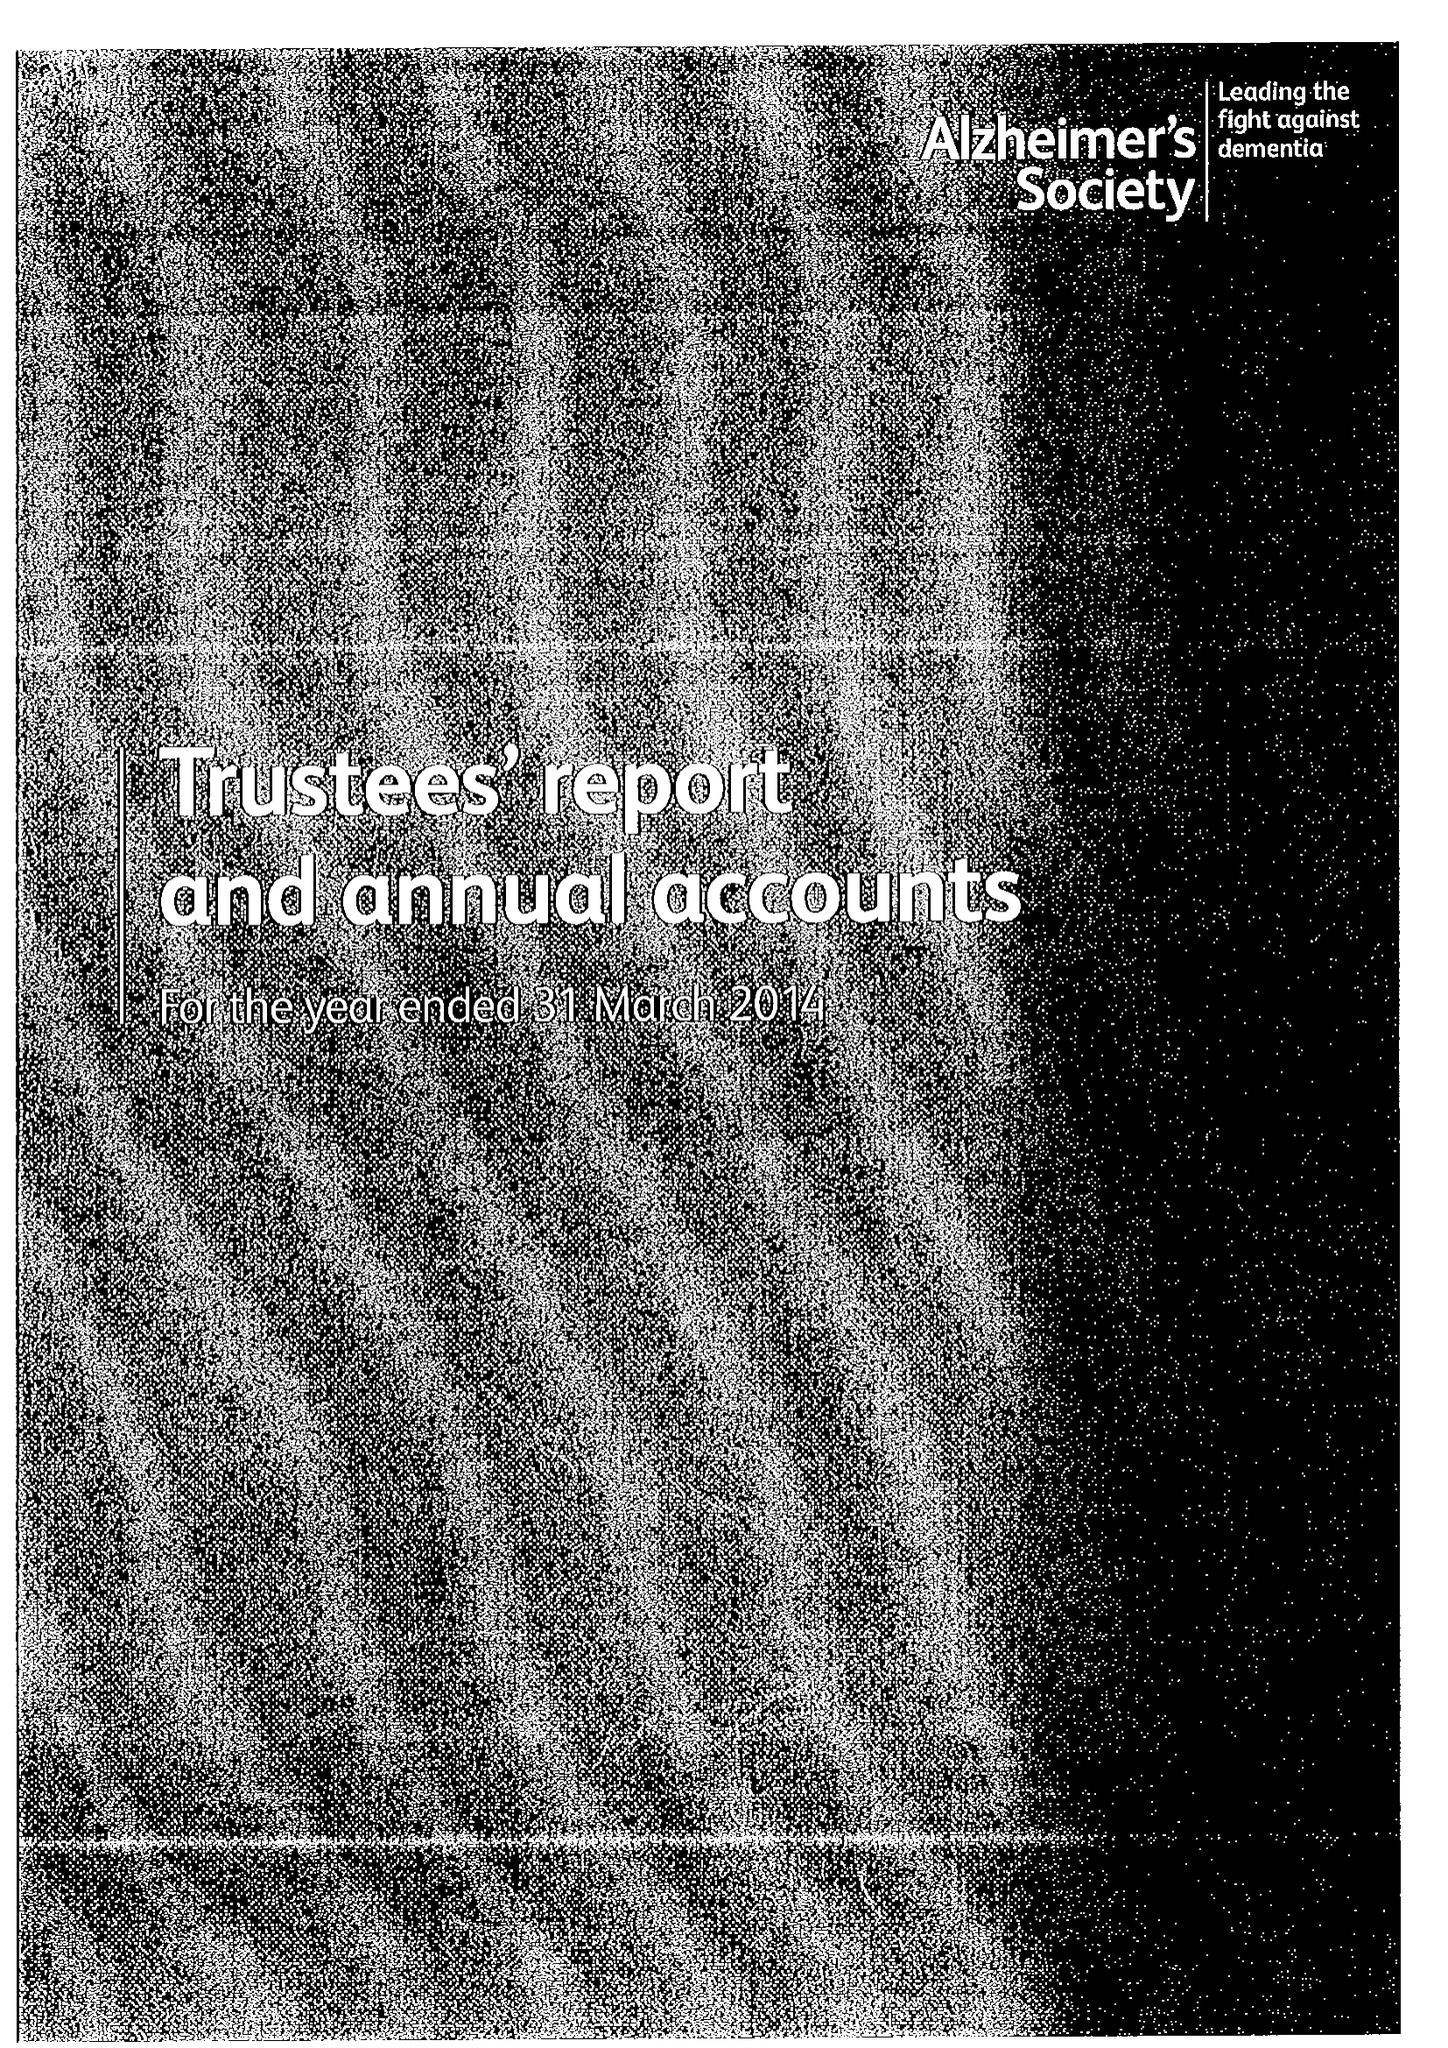What is the value for the charity_name?
Answer the question using a single word or phrase. Alzheimer's Society 